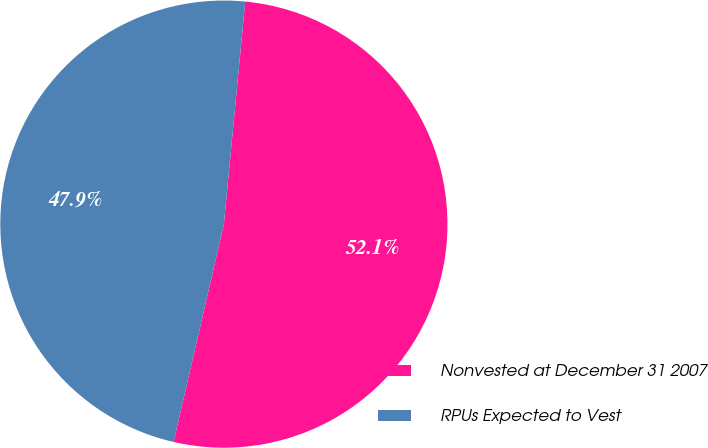Convert chart to OTSL. <chart><loc_0><loc_0><loc_500><loc_500><pie_chart><fcel>Nonvested at December 31 2007<fcel>RPUs Expected to Vest<nl><fcel>52.09%<fcel>47.91%<nl></chart> 